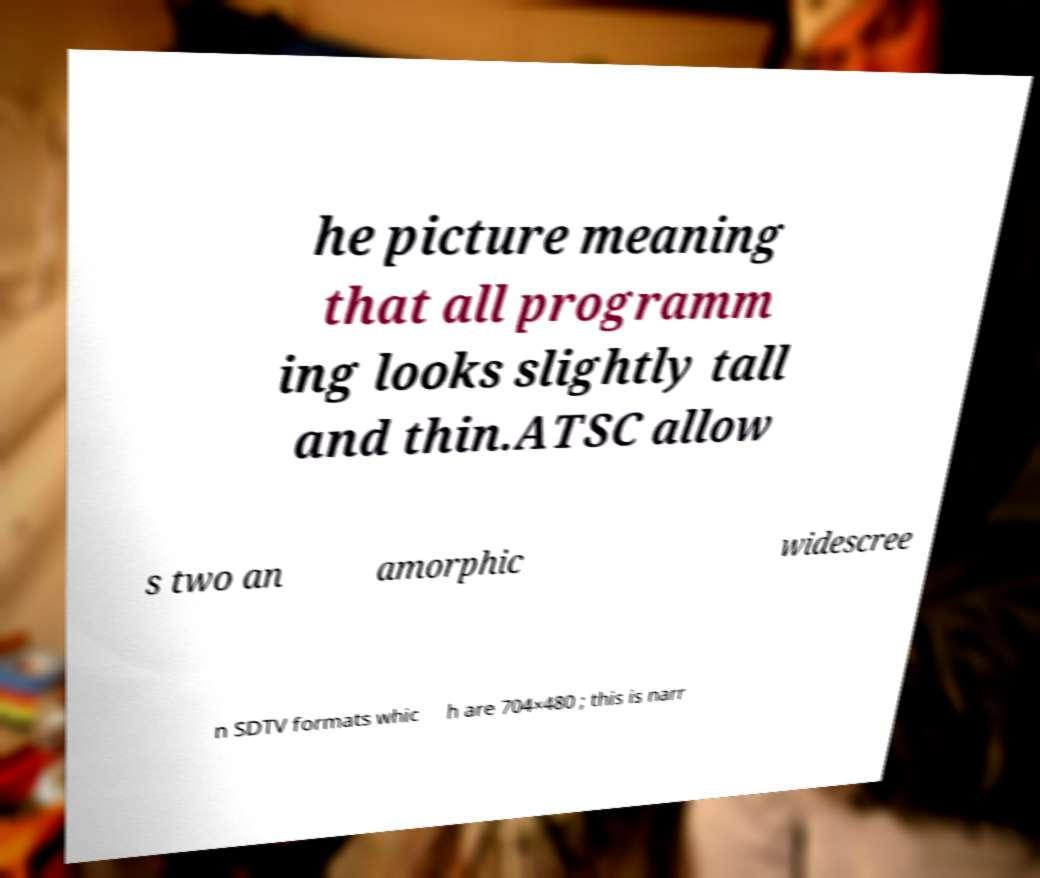For documentation purposes, I need the text within this image transcribed. Could you provide that? he picture meaning that all programm ing looks slightly tall and thin.ATSC allow s two an amorphic widescree n SDTV formats whic h are 704×480 ; this is narr 